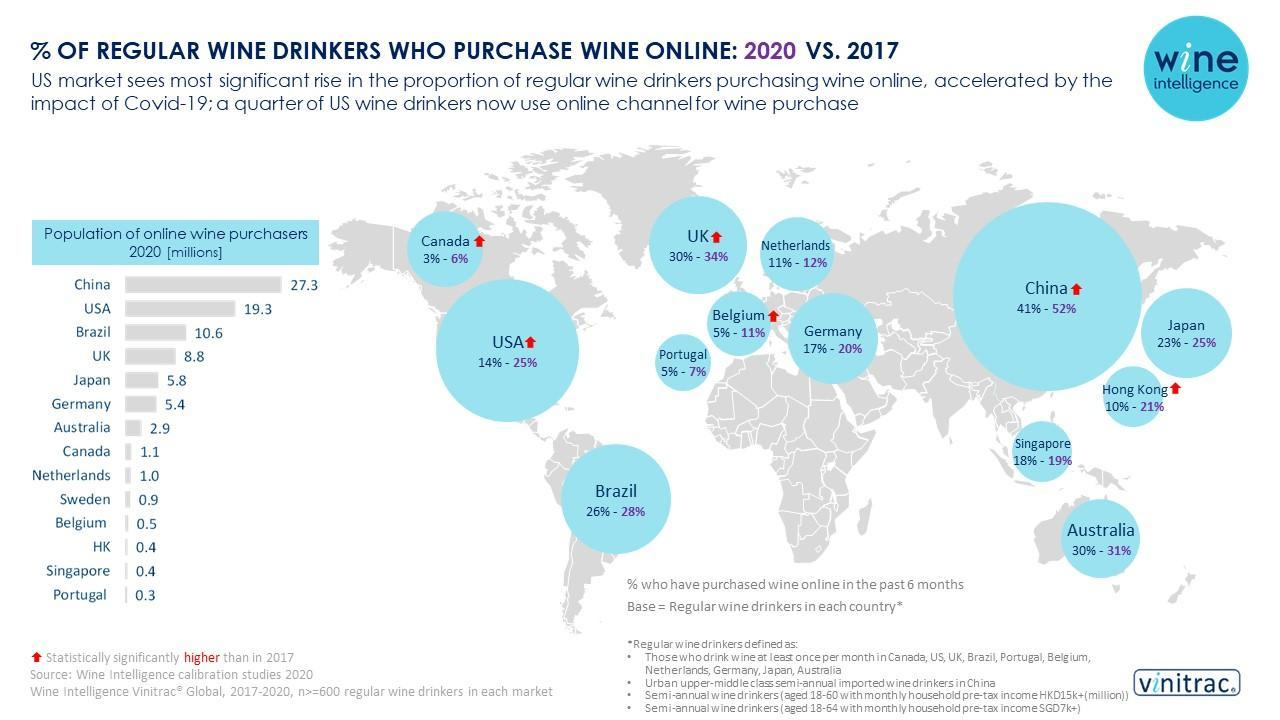What is the percentage of regular wine drinkers who purchase wine online in USA in the year 2020?
Answer the question with a short phrase. 25% Which country has the least population of online wine purchasers (in millions) in 2020? Portugal What is the population of online wine purchasers (in millions) in Canada in 2020? 1.1 Which country has the highest population of online wine purchasers (in millions) in 2020? China Which country has the second highest population of online wine purchasers (in millions) in 2020? USA Which country has the second least population of online wine purchasers (in millions) in 2020? Singapore What is the population of online wine purchasers (in millions) in Brazil in 2020? 10.6 What is the percentage of regular wine drinkers who purchase wine online in Singapore in the year 2017? 18% What is the percentage of regular wine drinkers who purchase wine online in China in the year 2020? 52% What is the percentage of regular wine drinkers who purchase wine online in Belgium in the year 2020? 11% 